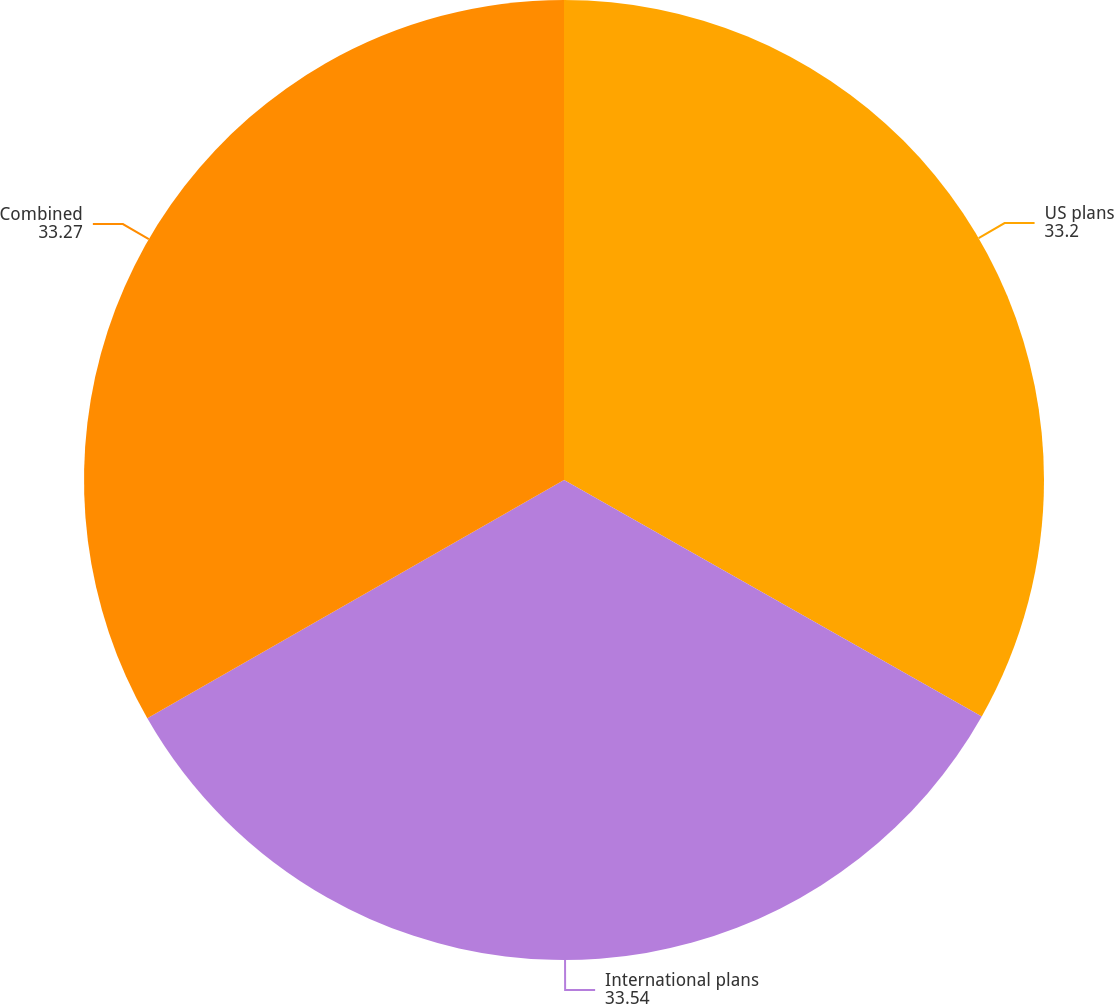<chart> <loc_0><loc_0><loc_500><loc_500><pie_chart><fcel>US plans<fcel>International plans<fcel>Combined<nl><fcel>33.2%<fcel>33.54%<fcel>33.27%<nl></chart> 